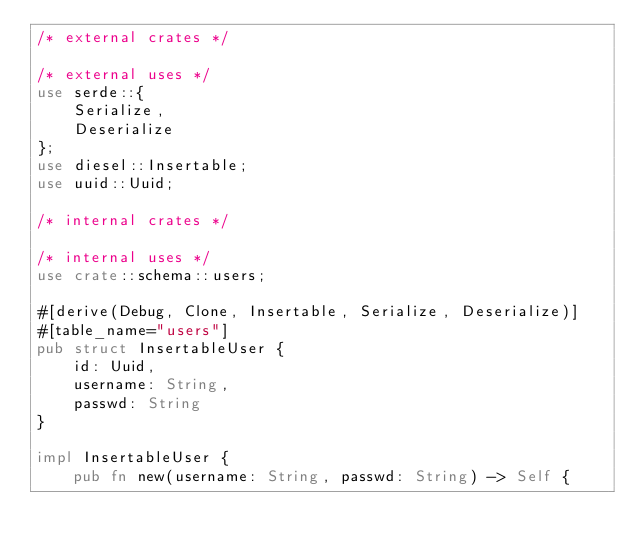<code> <loc_0><loc_0><loc_500><loc_500><_Rust_>/* external crates */

/* external uses */
use serde::{
    Serialize,
    Deserialize
};
use diesel::Insertable;
use uuid::Uuid;

/* internal crates */

/* internal uses */
use crate::schema::users;

#[derive(Debug, Clone, Insertable, Serialize, Deserialize)]
#[table_name="users"]
pub struct InsertableUser {
    id: Uuid,
    username: String,
    passwd: String
}

impl InsertableUser {
    pub fn new(username: String, passwd: String) -> Self {</code> 